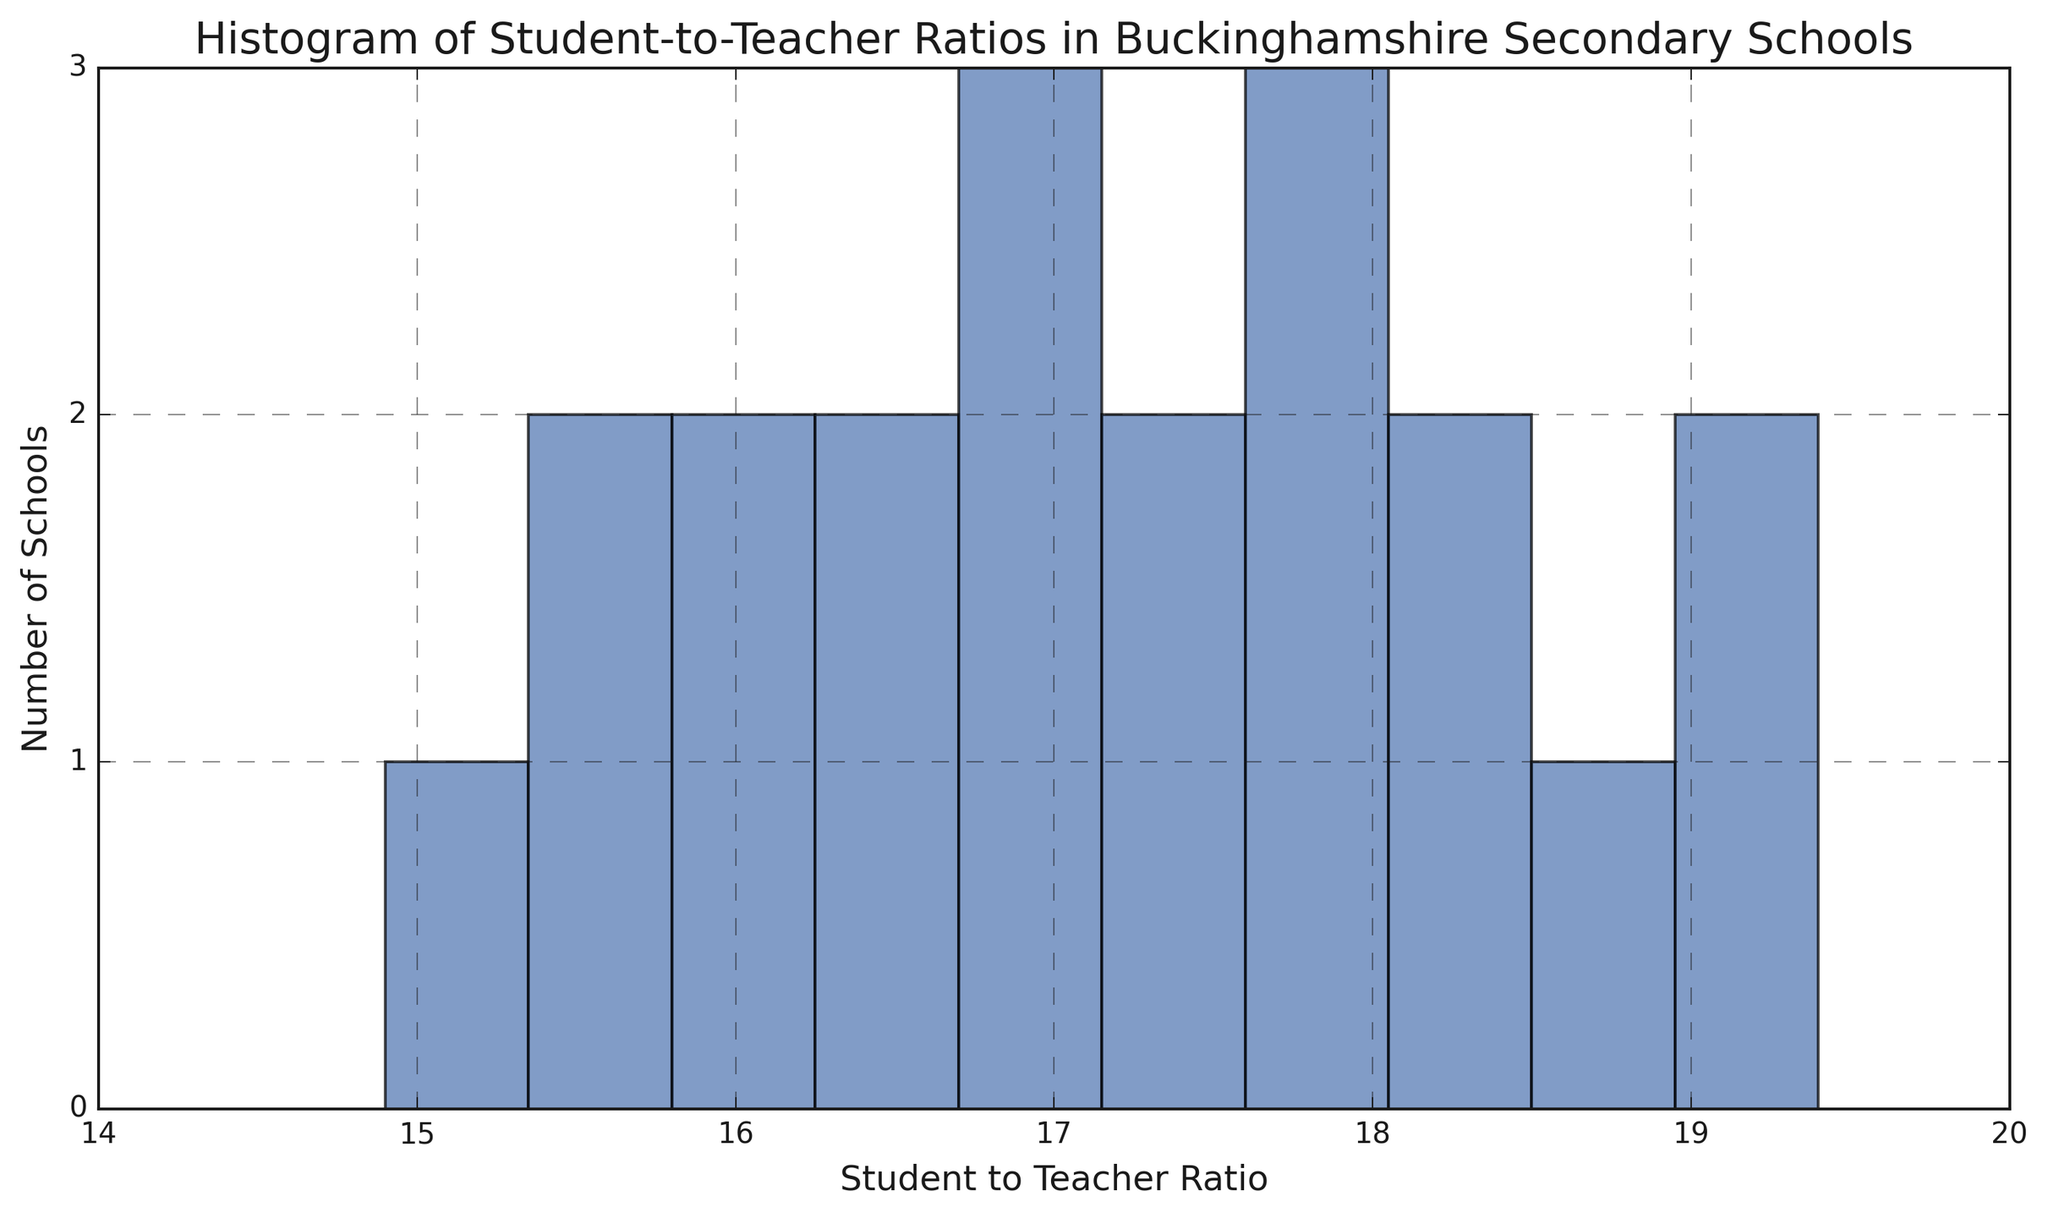What's the most common range of student-to-teacher ratios among the schools? By looking at the tallest bar in the histogram, we can identify the range of student-to-teacher ratios that is most common among schools. This is the mode of the distribution.
Answer: 16 to 17 How many schools have a student-to-teacher ratio greater than 18? Count the number of bars in the histogram where the student-to-teacher ratios are greater than 18. The total height of those bars represents the number of schools.
Answer: 4 Which student-to-teacher ratio range contains the fewest schools? Identify the bar with the shortest height in the histogram to determine which range has the fewest schools.
Answer: 14 to 15 Are there more schools with a student-to-teacher ratio below 17 or above 17? Calculate the total number of schools with ratios below 17 by summing the heights of the bars on the left of 17, then compare this with the total number of schools above 17 by summing the heights of bars on the right.
Answer: Below 17 What's the average student-to-teacher ratio across all schools? Sum the student-to-teacher ratios of all schools and divide by the number of schools (20). So, (16.1 + 17.3 + 15.8 + 18.0 + 16.4 + 15.7 + 17.1 + 14.9 + 16.8 + 16.3 + 18.2 + 17.6 + 19.1 + 18.9 + 16.7 + 17.8 + 19.4 + 18.3 + 17.5 + 15.4) / 20
Answer: 17.1 Is there an equal number of schools in the ranges 15 to 16 and 18 to 19? Add the heights of the bars from 15 to 16 and compare with the total heights of the bars from 18 to 19. Count the total number of schools in each range.
Answer: No How many schools have a student-to-teacher ratio between 16 and 18? Sum the heights of the histogram bars representing ratios from 16 to 18.
Answer: 10 Which range has more schools: 17 to 18 or 18 to 19? Compare the height of the bar in the 17 to 18 range to the combined heights of the bars in the 18 to 19 range.
Answer: 18 to 19 Does any range contain exactly three schools? Look for any bar in the histogram with a height of exactly three units, representing three schools.
Answer: No 